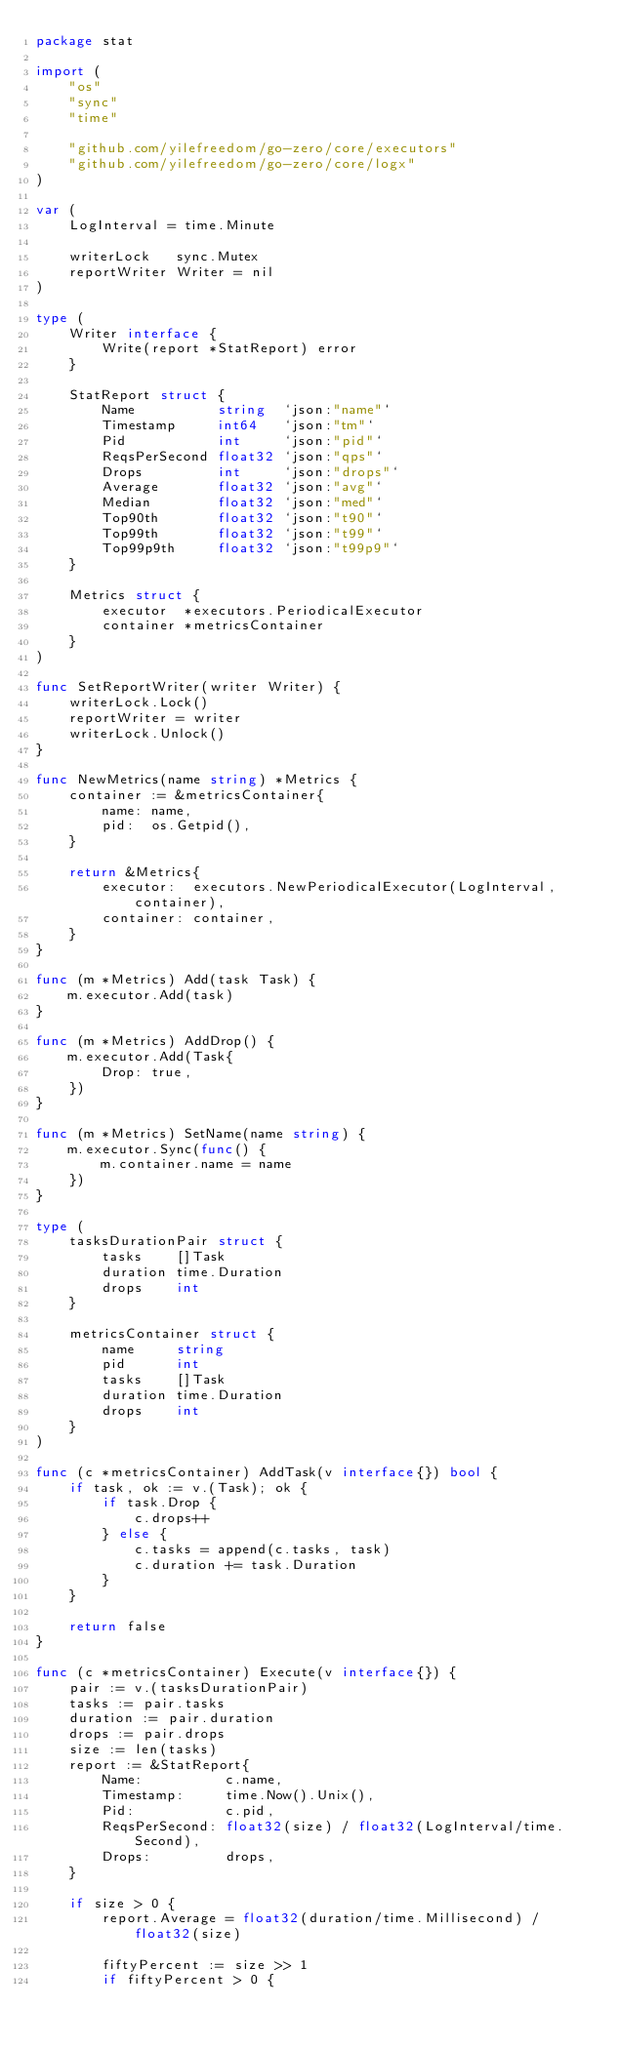Convert code to text. <code><loc_0><loc_0><loc_500><loc_500><_Go_>package stat

import (
	"os"
	"sync"
	"time"

	"github.com/yilefreedom/go-zero/core/executors"
	"github.com/yilefreedom/go-zero/core/logx"
)

var (
	LogInterval = time.Minute

	writerLock   sync.Mutex
	reportWriter Writer = nil
)

type (
	Writer interface {
		Write(report *StatReport) error
	}

	StatReport struct {
		Name          string  `json:"name"`
		Timestamp     int64   `json:"tm"`
		Pid           int     `json:"pid"`
		ReqsPerSecond float32 `json:"qps"`
		Drops         int     `json:"drops"`
		Average       float32 `json:"avg"`
		Median        float32 `json:"med"`
		Top90th       float32 `json:"t90"`
		Top99th       float32 `json:"t99"`
		Top99p9th     float32 `json:"t99p9"`
	}

	Metrics struct {
		executor  *executors.PeriodicalExecutor
		container *metricsContainer
	}
)

func SetReportWriter(writer Writer) {
	writerLock.Lock()
	reportWriter = writer
	writerLock.Unlock()
}

func NewMetrics(name string) *Metrics {
	container := &metricsContainer{
		name: name,
		pid:  os.Getpid(),
	}

	return &Metrics{
		executor:  executors.NewPeriodicalExecutor(LogInterval, container),
		container: container,
	}
}

func (m *Metrics) Add(task Task) {
	m.executor.Add(task)
}

func (m *Metrics) AddDrop() {
	m.executor.Add(Task{
		Drop: true,
	})
}

func (m *Metrics) SetName(name string) {
	m.executor.Sync(func() {
		m.container.name = name
	})
}

type (
	tasksDurationPair struct {
		tasks    []Task
		duration time.Duration
		drops    int
	}

	metricsContainer struct {
		name     string
		pid      int
		tasks    []Task
		duration time.Duration
		drops    int
	}
)

func (c *metricsContainer) AddTask(v interface{}) bool {
	if task, ok := v.(Task); ok {
		if task.Drop {
			c.drops++
		} else {
			c.tasks = append(c.tasks, task)
			c.duration += task.Duration
		}
	}

	return false
}

func (c *metricsContainer) Execute(v interface{}) {
	pair := v.(tasksDurationPair)
	tasks := pair.tasks
	duration := pair.duration
	drops := pair.drops
	size := len(tasks)
	report := &StatReport{
		Name:          c.name,
		Timestamp:     time.Now().Unix(),
		Pid:           c.pid,
		ReqsPerSecond: float32(size) / float32(LogInterval/time.Second),
		Drops:         drops,
	}

	if size > 0 {
		report.Average = float32(duration/time.Millisecond) / float32(size)

		fiftyPercent := size >> 1
		if fiftyPercent > 0 {</code> 